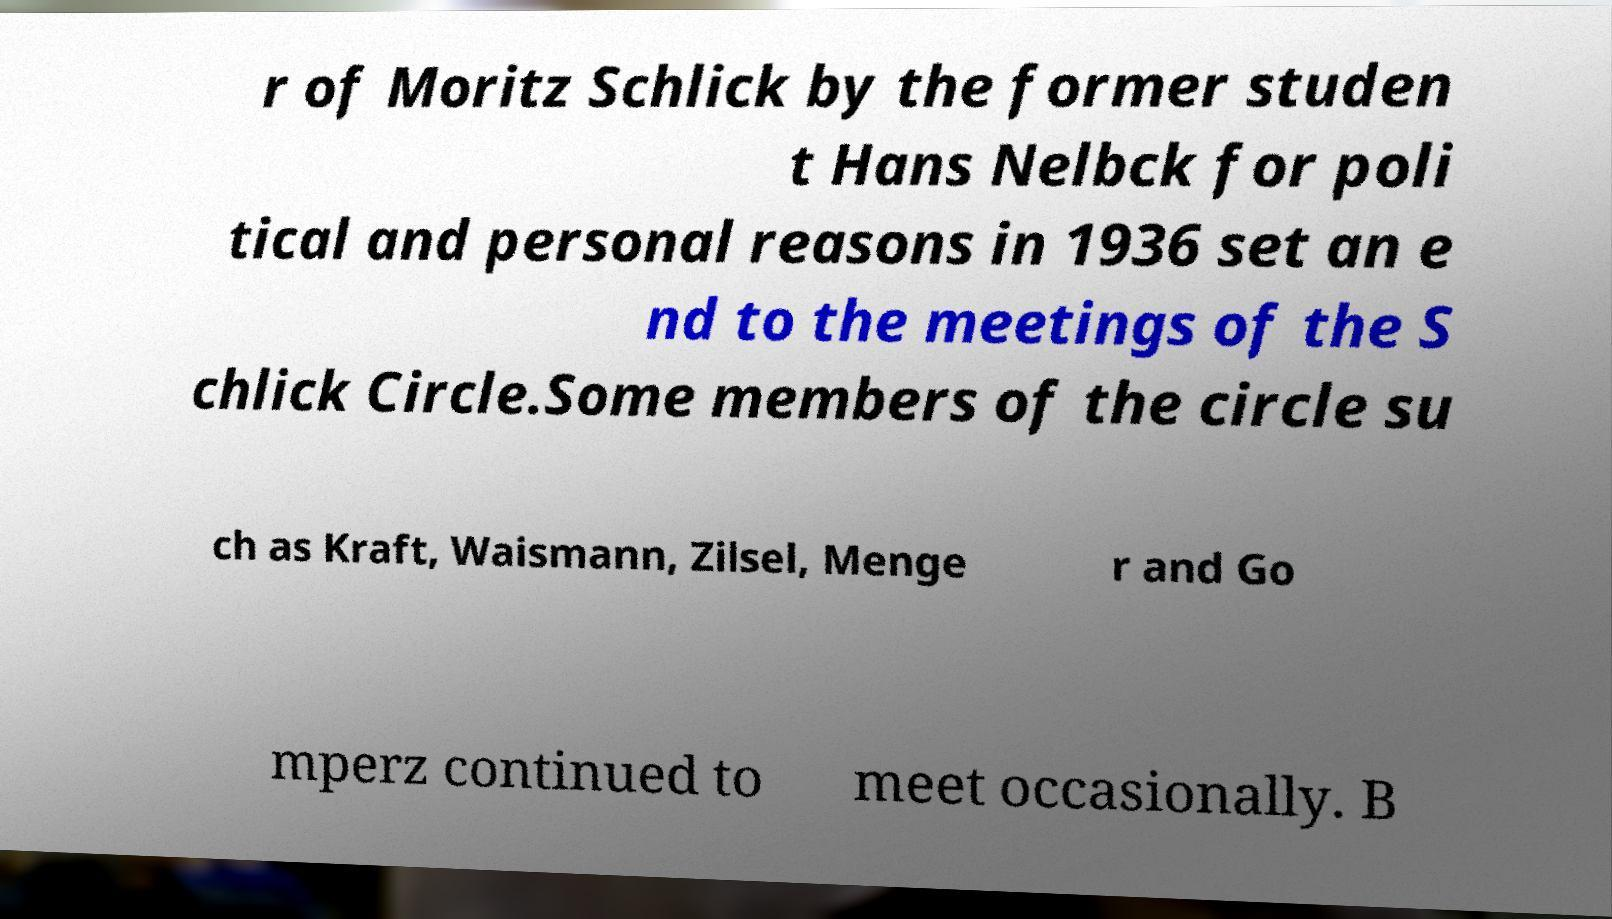I need the written content from this picture converted into text. Can you do that? r of Moritz Schlick by the former studen t Hans Nelbck for poli tical and personal reasons in 1936 set an e nd to the meetings of the S chlick Circle.Some members of the circle su ch as Kraft, Waismann, Zilsel, Menge r and Go mperz continued to meet occasionally. B 